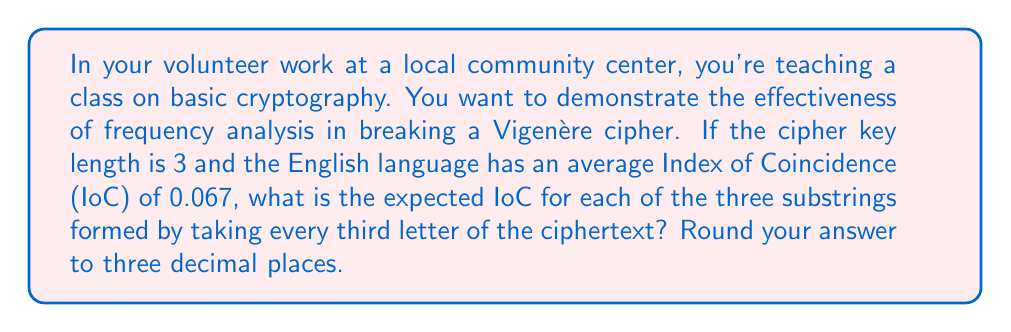Can you solve this math problem? Let's approach this step-by-step:

1) The Vigenère cipher with a key length of 3 essentially creates three separate Caesar ciphers, one for each position in the key.

2) When we separate the ciphertext into three substrings (taking every third letter), each substring corresponds to one of these Caesar ciphers.

3) A Caesar cipher is a monoalphabetic substitution cipher, which preserves the frequency distribution of the original text.

4) The Index of Coincidence (IoC) measures the unevenness of the frequency distribution in a text. For a completely random text, the IoC would be about 0.038 (1/26), while for meaningful text in English, it's typically around 0.067.

5) Since each substring is effectively encrypted with a Caesar cipher, it should maintain the IoC of the original text.

6) Therefore, we expect each substring to have approximately the same IoC as typical English text.

7) The given IoC for English is 0.067.

Thus, we expect each of the three substrings to have an IoC of approximately 0.067.
Answer: 0.067 